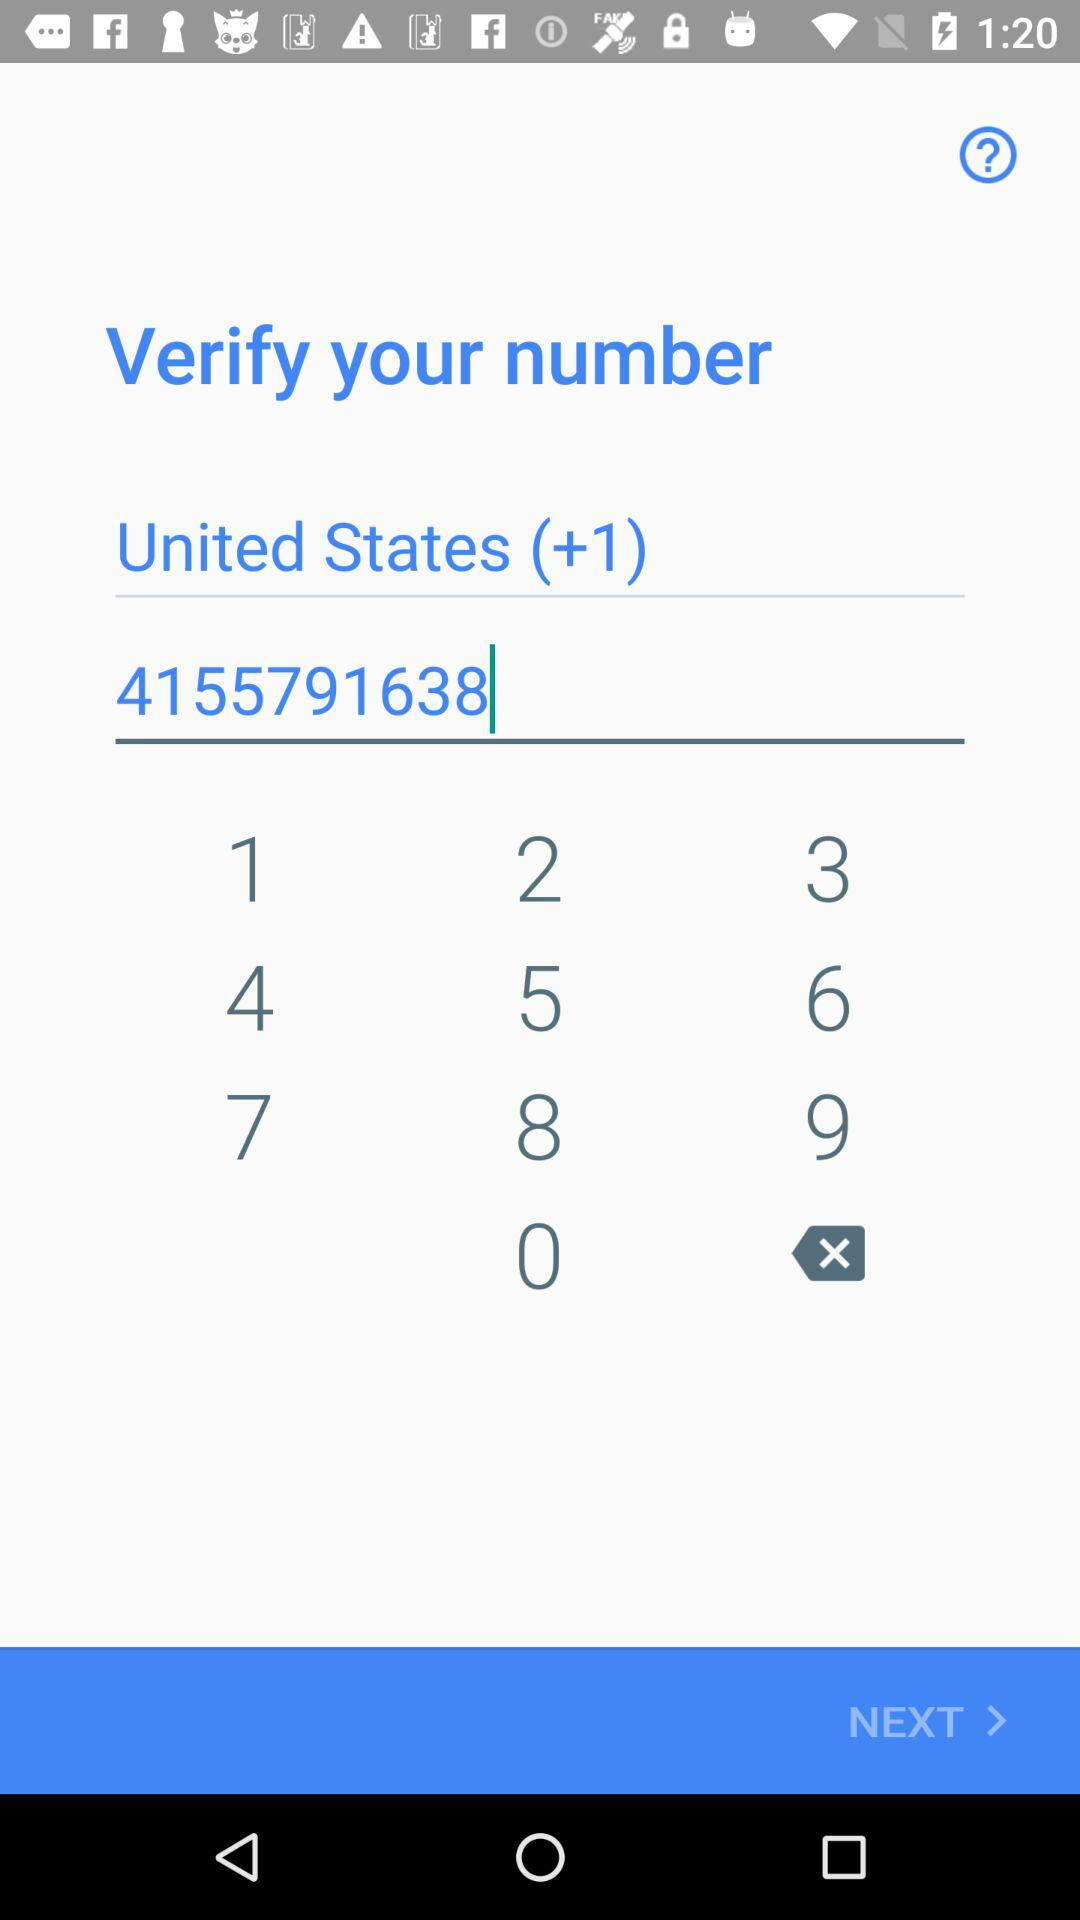What is the phone number? The phone number is 4155791638. 